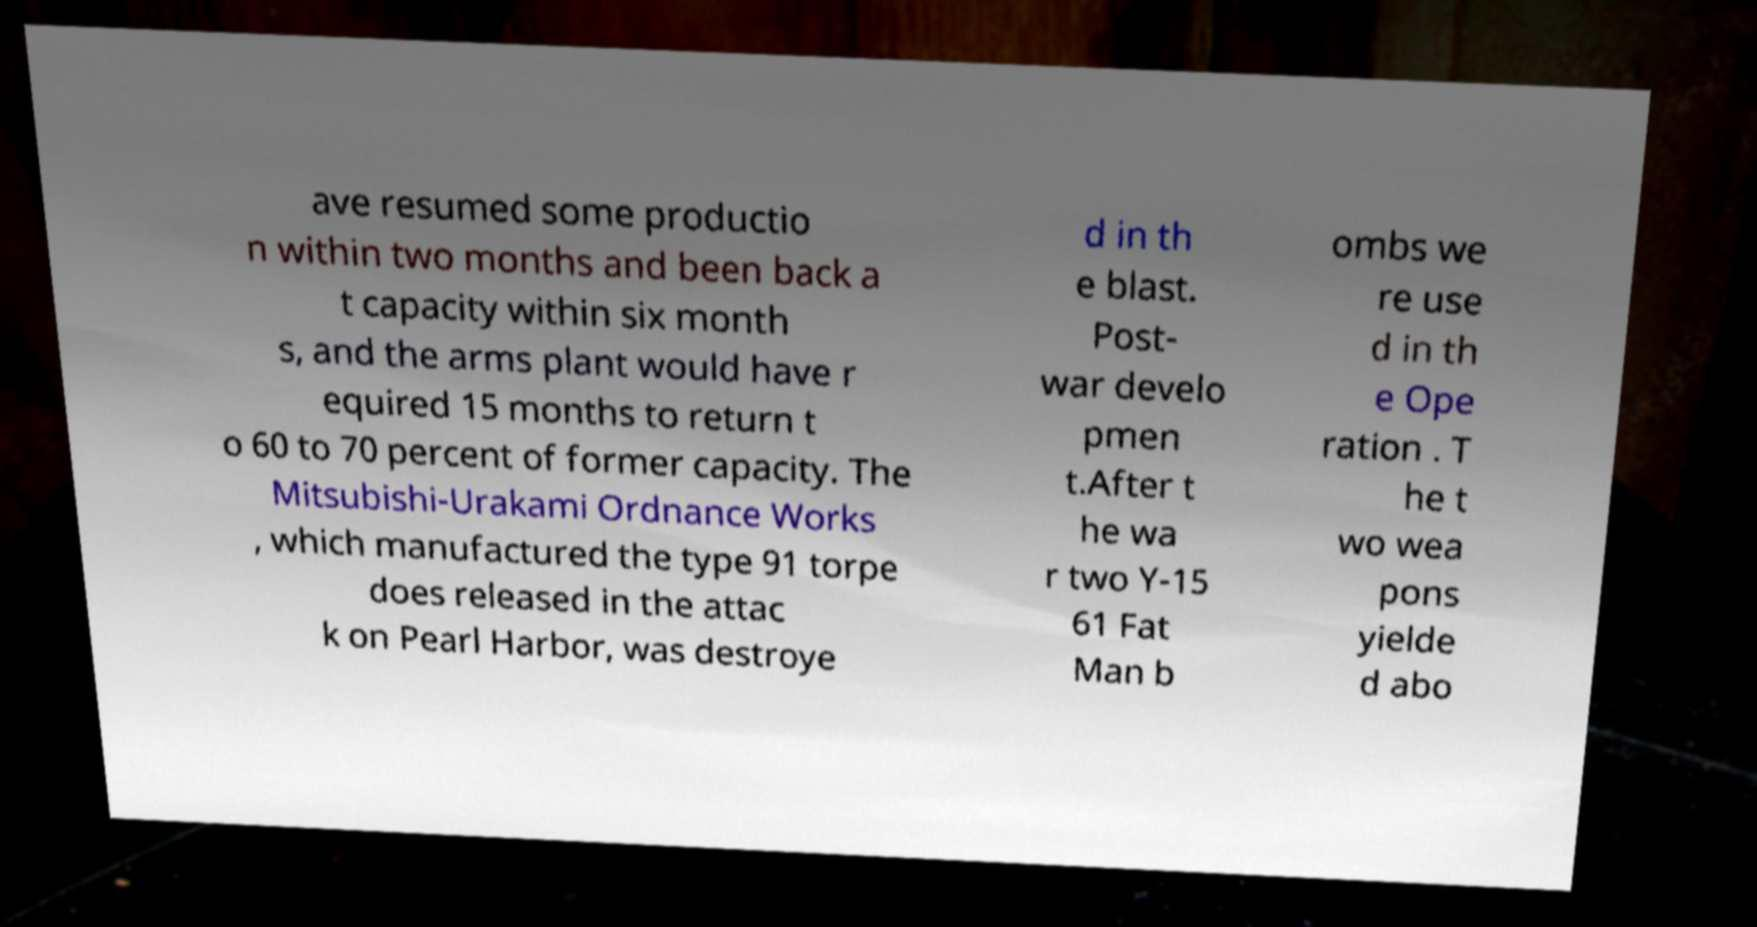I need the written content from this picture converted into text. Can you do that? ave resumed some productio n within two months and been back a t capacity within six month s, and the arms plant would have r equired 15 months to return t o 60 to 70 percent of former capacity. The Mitsubishi-Urakami Ordnance Works , which manufactured the type 91 torpe does released in the attac k on Pearl Harbor, was destroye d in th e blast. Post- war develo pmen t.After t he wa r two Y-15 61 Fat Man b ombs we re use d in th e Ope ration . T he t wo wea pons yielde d abo 